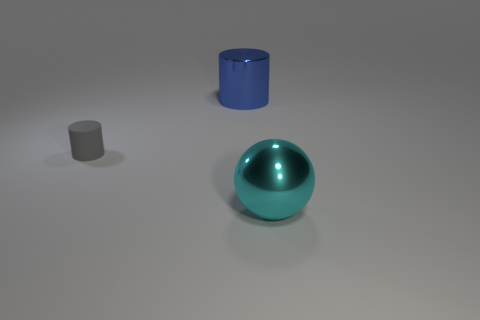Add 2 large red balls. How many large red balls exist? 2 Add 1 small matte things. How many objects exist? 4 Subtract all gray cylinders. How many cylinders are left? 1 Subtract 0 green blocks. How many objects are left? 3 Subtract all spheres. How many objects are left? 2 Subtract 1 balls. How many balls are left? 0 Subtract all red cylinders. Subtract all yellow spheres. How many cylinders are left? 2 Subtract all blue spheres. How many brown cylinders are left? 0 Subtract all blue cylinders. Subtract all cyan spheres. How many objects are left? 1 Add 1 small objects. How many small objects are left? 2 